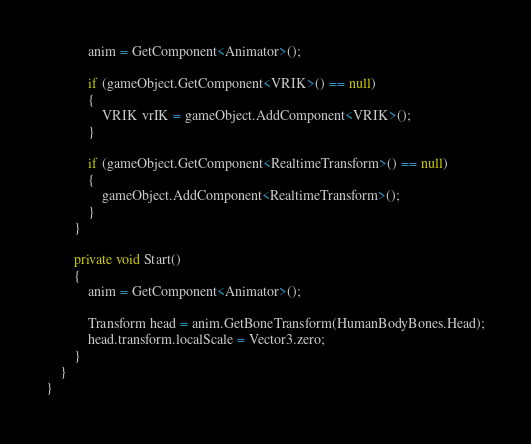Convert code to text. <code><loc_0><loc_0><loc_500><loc_500><_C#_>			anim = GetComponent<Animator>();

			if (gameObject.GetComponent<VRIK>() == null)
			{
				VRIK vrIK = gameObject.AddComponent<VRIK>();
			}

			if (gameObject.GetComponent<RealtimeTransform>() == null)
			{
				gameObject.AddComponent<RealtimeTransform>();
			}
		}

		private void Start()
		{
			anim = GetComponent<Animator>();

			Transform head = anim.GetBoneTransform(HumanBodyBones.Head);
			head.transform.localScale = Vector3.zero;
		}
	}
}</code> 